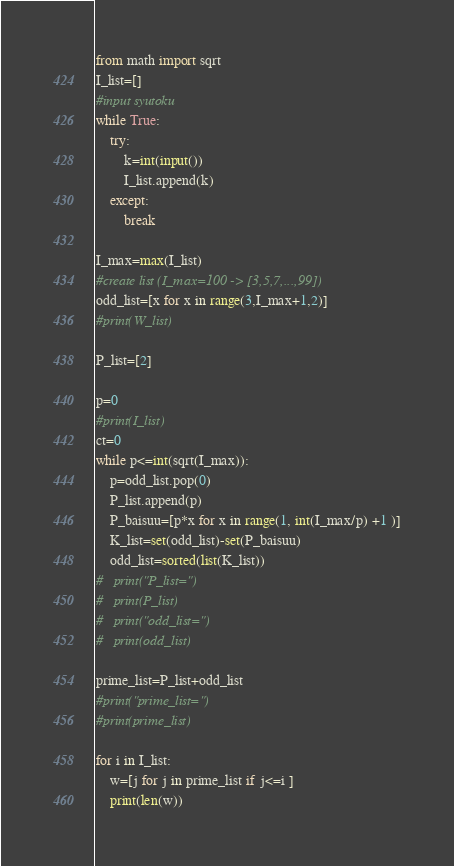Convert code to text. <code><loc_0><loc_0><loc_500><loc_500><_Python_>from math import sqrt
I_list=[]
#input syutoku
while True:
	try:
		k=int(input())
		I_list.append(k)
	except:
		break

I_max=max(I_list)
#create list (I_max=100 -> [3,5,7,...,99])
odd_list=[x for x in range(3,I_max+1,2)]
#print(W_list)

P_list=[2]

p=0
#print(I_list)
ct=0
while p<=int(sqrt(I_max)):
	p=odd_list.pop(0)
	P_list.append(p)
	P_baisuu=[p*x for x in range(1, int(I_max/p) +1 )]
	K_list=set(odd_list)-set(P_baisuu)
	odd_list=sorted(list(K_list))
#	print("P_list=")
#	print(P_list)
#	print("odd_list=")
#	print(odd_list)

prime_list=P_list+odd_list
#print("prime_list=")
#print(prime_list)

for i in I_list:
	w=[j for j in prime_list if j<=i ]
	print(len(w)) </code> 